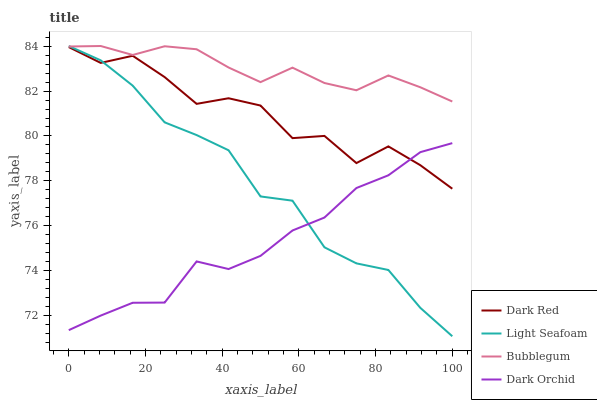Does Light Seafoam have the minimum area under the curve?
Answer yes or no. No. Does Light Seafoam have the maximum area under the curve?
Answer yes or no. No. Is Light Seafoam the smoothest?
Answer yes or no. No. Is Light Seafoam the roughest?
Answer yes or no. No. Does Dark Orchid have the lowest value?
Answer yes or no. No. Does Dark Orchid have the highest value?
Answer yes or no. No. Is Dark Red less than Bubblegum?
Answer yes or no. Yes. Is Bubblegum greater than Dark Red?
Answer yes or no. Yes. Does Dark Red intersect Bubblegum?
Answer yes or no. No. 